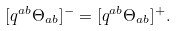Convert formula to latex. <formula><loc_0><loc_0><loc_500><loc_500>[ q ^ { a b } \Theta _ { a b } ] ^ { - } = [ q ^ { a b } \Theta _ { a b } ] ^ { + } .</formula> 